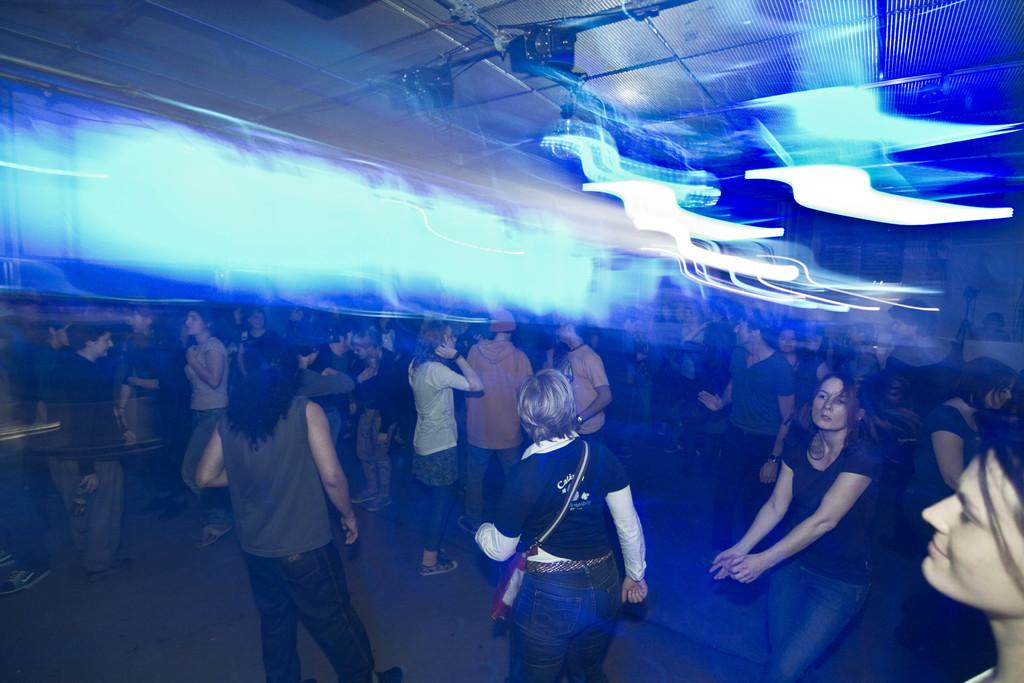What is happening in the image involving a group of people? Some of the people are dancing in the image. What can be seen on the ceiling in the image? There are lights on the ceiling in the image. What type of leg is visible on the person wearing a skirt in the image? There is no person wearing a skirt in the image, nor is there any leg visible. Can you tell me how many frogs are present in the image? There are no frogs present in the image. 